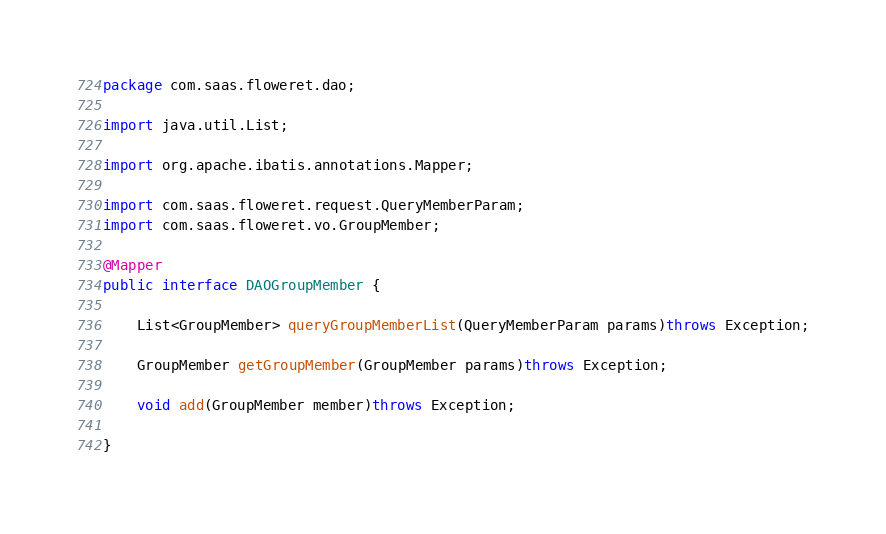Convert code to text. <code><loc_0><loc_0><loc_500><loc_500><_Java_>package com.saas.floweret.dao;

import java.util.List;

import org.apache.ibatis.annotations.Mapper;

import com.saas.floweret.request.QueryMemberParam;
import com.saas.floweret.vo.GroupMember;

@Mapper
public interface DAOGroupMember {

	List<GroupMember> queryGroupMemberList(QueryMemberParam params)throws Exception;

	GroupMember getGroupMember(GroupMember params)throws Exception;

	void add(GroupMember member)throws Exception;

}
</code> 